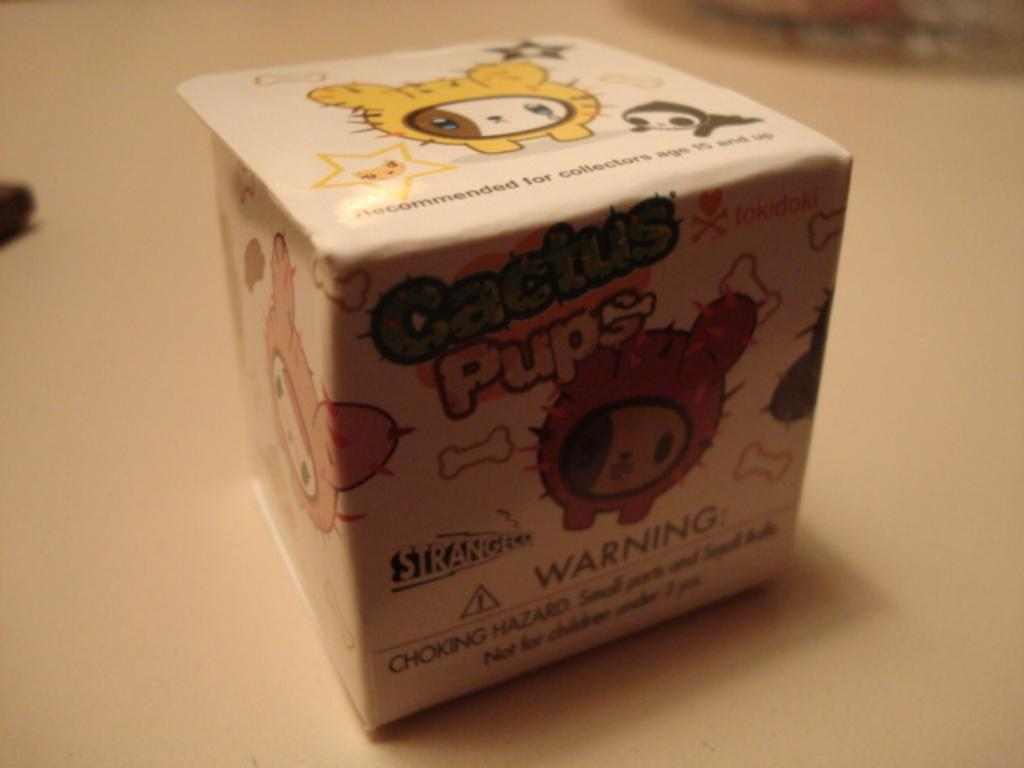Provide a one-sentence caption for the provided image. a box that is labeled as cactus pups that has a warning label at the bottom of it. 